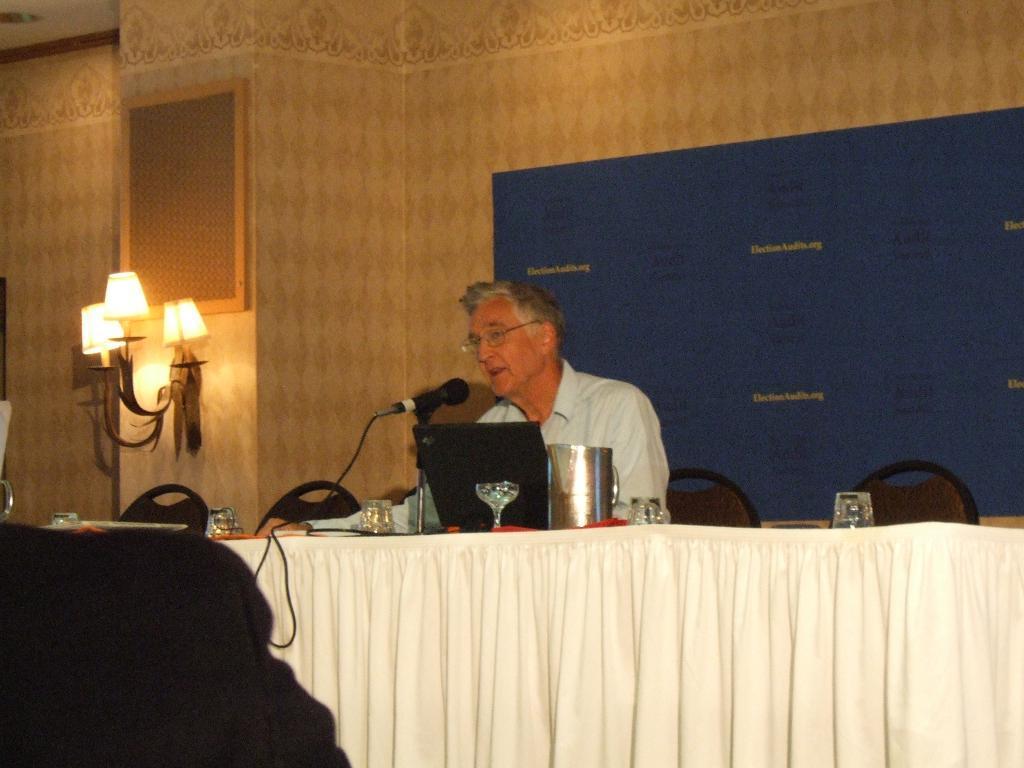Describe this image in one or two sentences. In this picture I can see a man seated on the chair and I can see few glasses, a laptop and a microphone to the stand and a jug on the table and I can see cloth to the table and few lights on the wall and a board with some text on the back and a frame on the wall. 